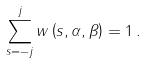Convert formula to latex. <formula><loc_0><loc_0><loc_500><loc_500>\sum _ { s = - j } ^ { j } w \left ( s , \alpha , \beta \right ) = 1 \, .</formula> 